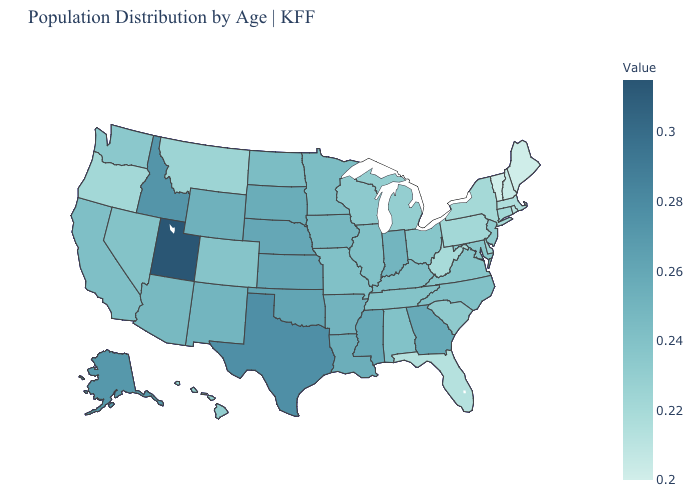Among the states that border Alabama , which have the lowest value?
Be succinct. Florida. Does Florida have the lowest value in the South?
Give a very brief answer. Yes. Does Arizona have the lowest value in the West?
Give a very brief answer. No. Does Florida have the highest value in the South?
Write a very short answer. No. Does Alabama have a higher value than Florida?
Concise answer only. Yes. 